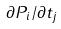<formula> <loc_0><loc_0><loc_500><loc_500>\partial P _ { i } / \partial t _ { j }</formula> 